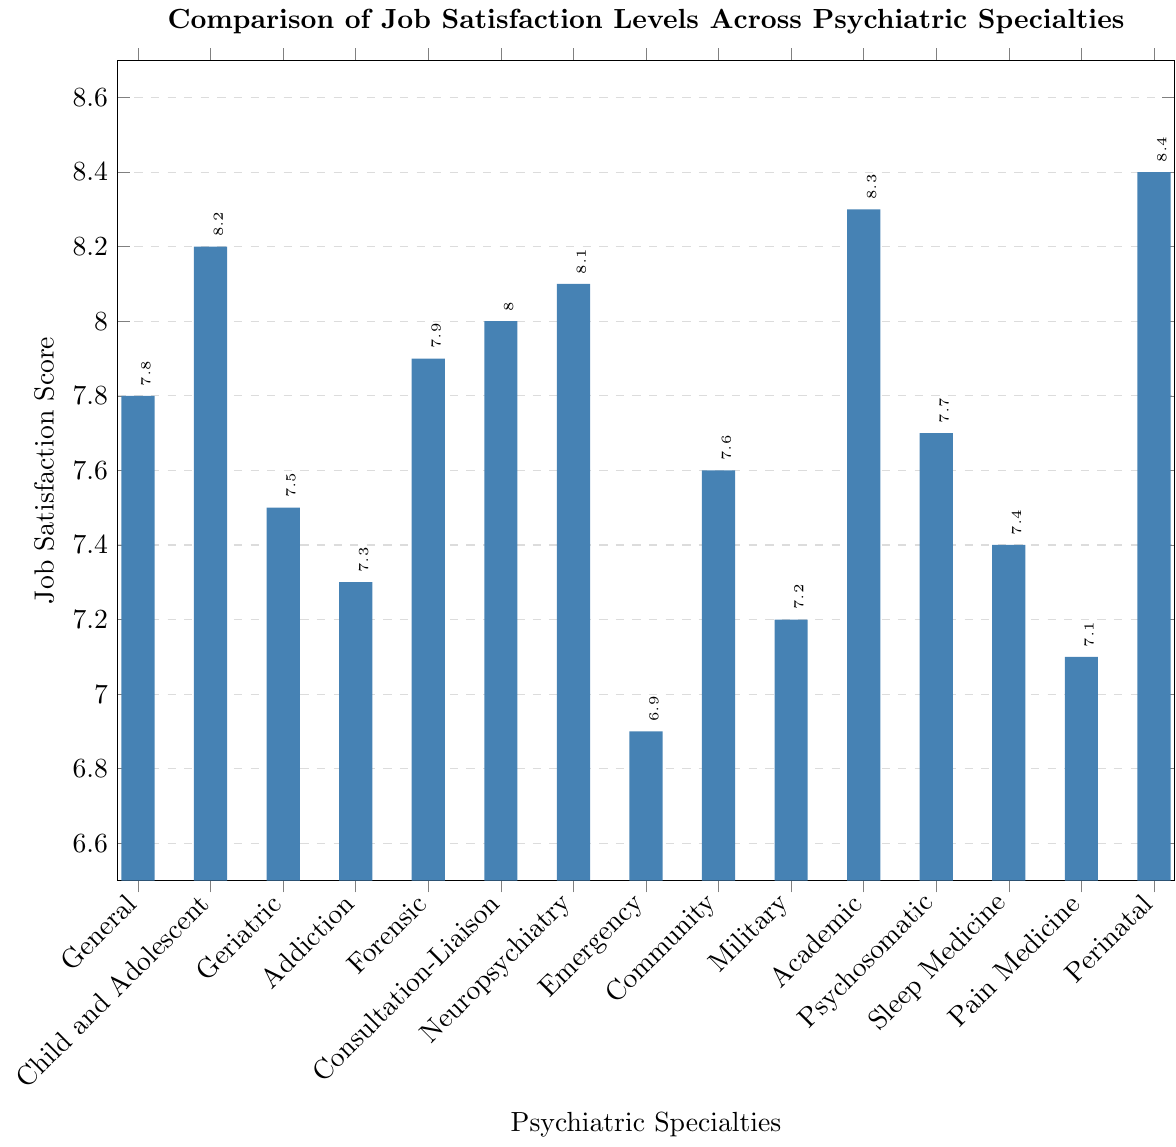Which psychiatric specialty has the highest job satisfaction score? By looking at the figure, identify the bar that extends the highest vertically on the plot. The highest bar corresponds to the specialty with the highest job satisfaction score.
Answer: Perinatal Psychiatry What is the job satisfaction score for Emergency Psychiatry? Find the bar labeled "Emergency" on the x-axis, and look at the height of the bar to determine the job satisfaction score.
Answer: 6.9 Which specialty has a higher job satisfaction score: Addiction Psychiatry or Military Psychiatry? Compare the heights of the bars labeled "Addiction" and "Military" on the x-axis to see which is higher.
Answer: Addiction Psychiatry What is the difference in job satisfaction scores between Academic Psychiatry and Geriatric Psychiatry? Locate the bars for "Academic" and "Geriatric." The job satisfaction score for Academic Psychiatry is 8.3, and for Geriatric Psychiatry, it is 7.5. Subtract 7.5 from 8.3.
Answer: 0.8 Among Community Psychiatry, Neuropsychiatry, and Consultation-Liaison Psychiatry, which has the second highest job satisfaction score? Examine the bars for "Community," "Neuropsychiatry," and "Consultation-Liaison." The job satisfaction scores are 7.6, 8.1, and 8.0, respectively. The second-highest score among them is 8.0.
Answer: Consultation-Liaison Psychiatry What is the range of job satisfaction scores across all specialties? Identify the highest and lowest job satisfaction scores from the bars on the chart. The highest is 8.4 and the lowest is 6.9. Subtract the lowest score from the highest score.
Answer: 1.5 How many specialties have a job satisfaction score above 8? Count the bars that reach above the score of 8 on the y-axis. The specialties are Child and Adolescent, Neuropsychiatry, Consultation-Liaison, Academic, and Perinatal Psychiatry.
Answer: 5 What is the average job satisfaction score for the specialties listed in the plot? Sum the job satisfaction scores: (7.8 + 8.2 + 7.5 + 7.3 + 7.9 + 8.0 + 8.1 + 6.9 + 7.6 + 7.2 + 8.3 + 7.7 + 7.4 + 7.1 + 8.4) and divide by the number of specialties, which is 15. (113.3 / 15 = 7.5533)
Answer: 7.55 Which specialties have a job satisfaction score that is exactly 7.1? Locate the bar that reaches the job satisfaction score of 7.1 on the y-axis.
Answer: Pain Medicine Is the job satisfaction score for Consultation-Liaison Psychiatry greater than the score for Forensic Psychiatry? Compare the heights of the bars for "Consultation-Liaison" and "Forensic."
Answer: No 